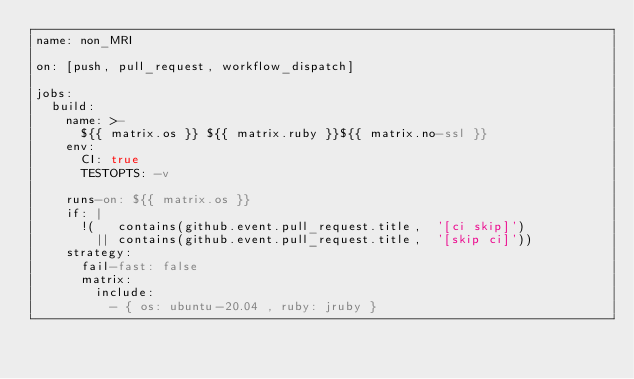<code> <loc_0><loc_0><loc_500><loc_500><_YAML_>name: non_MRI

on: [push, pull_request, workflow_dispatch]

jobs:
  build:
    name: >-
      ${{ matrix.os }} ${{ matrix.ruby }}${{ matrix.no-ssl }}
    env:
      CI: true
      TESTOPTS: -v

    runs-on: ${{ matrix.os }}
    if: |
      !(   contains(github.event.pull_request.title,  '[ci skip]')
        || contains(github.event.pull_request.title,  '[skip ci]'))
    strategy:
      fail-fast: false
      matrix:
        include:
          - { os: ubuntu-20.04 , ruby: jruby }</code> 